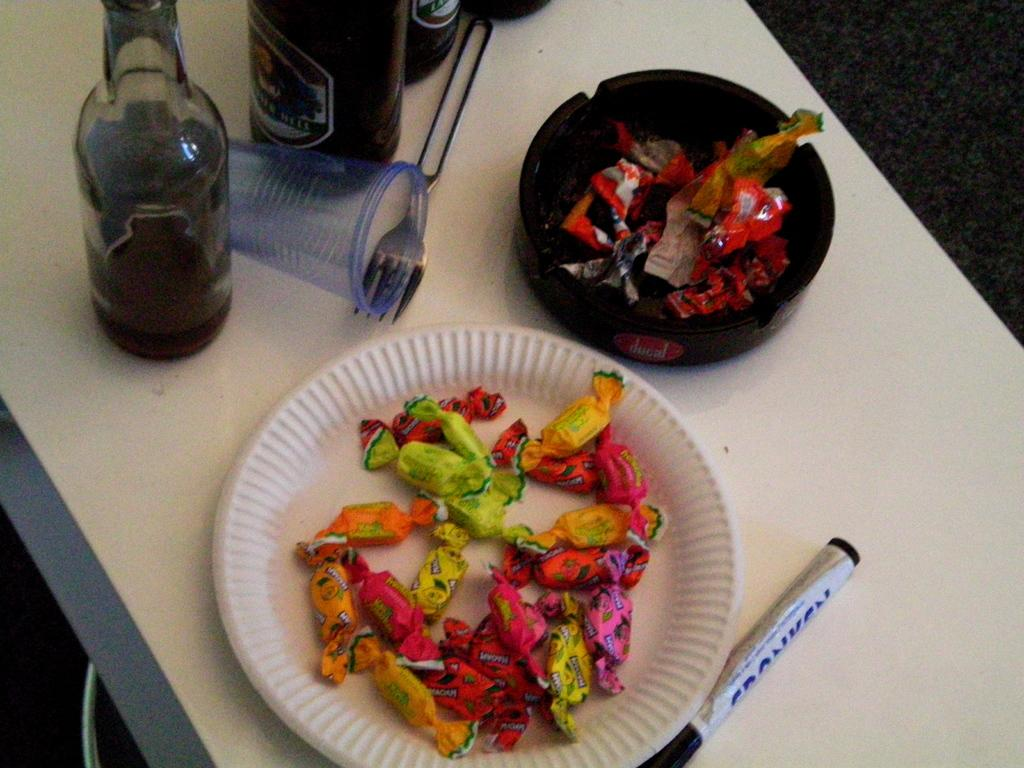What type of food is on the plate in the image? There are chocolates on a plate in the image. What is located on the table in the image? There is a marker, a fork, disposable glasses, and wine bottles on the table. What might be used for writing in the image? The marker on the table might be used for writing. What might be used for consuming beverages in the image? The disposable glasses on the table might be used for consuming beverages. What type of cart is being used to transport the wine bottles in the image? There is no cart present in the image; the wine bottles are on the table. 